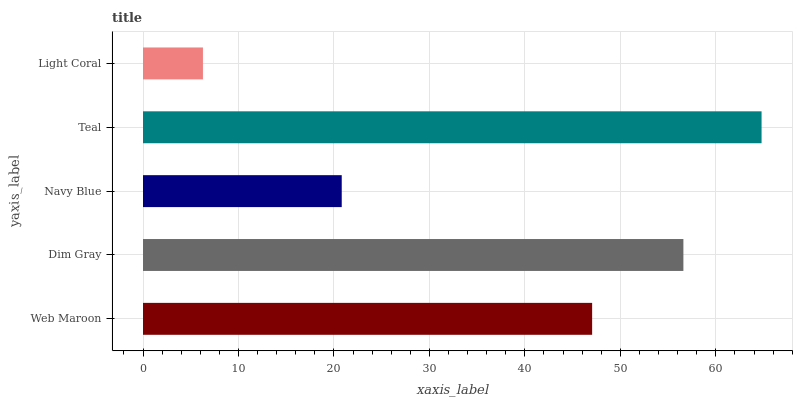Is Light Coral the minimum?
Answer yes or no. Yes. Is Teal the maximum?
Answer yes or no. Yes. Is Dim Gray the minimum?
Answer yes or no. No. Is Dim Gray the maximum?
Answer yes or no. No. Is Dim Gray greater than Web Maroon?
Answer yes or no. Yes. Is Web Maroon less than Dim Gray?
Answer yes or no. Yes. Is Web Maroon greater than Dim Gray?
Answer yes or no. No. Is Dim Gray less than Web Maroon?
Answer yes or no. No. Is Web Maroon the high median?
Answer yes or no. Yes. Is Web Maroon the low median?
Answer yes or no. Yes. Is Light Coral the high median?
Answer yes or no. No. Is Dim Gray the low median?
Answer yes or no. No. 